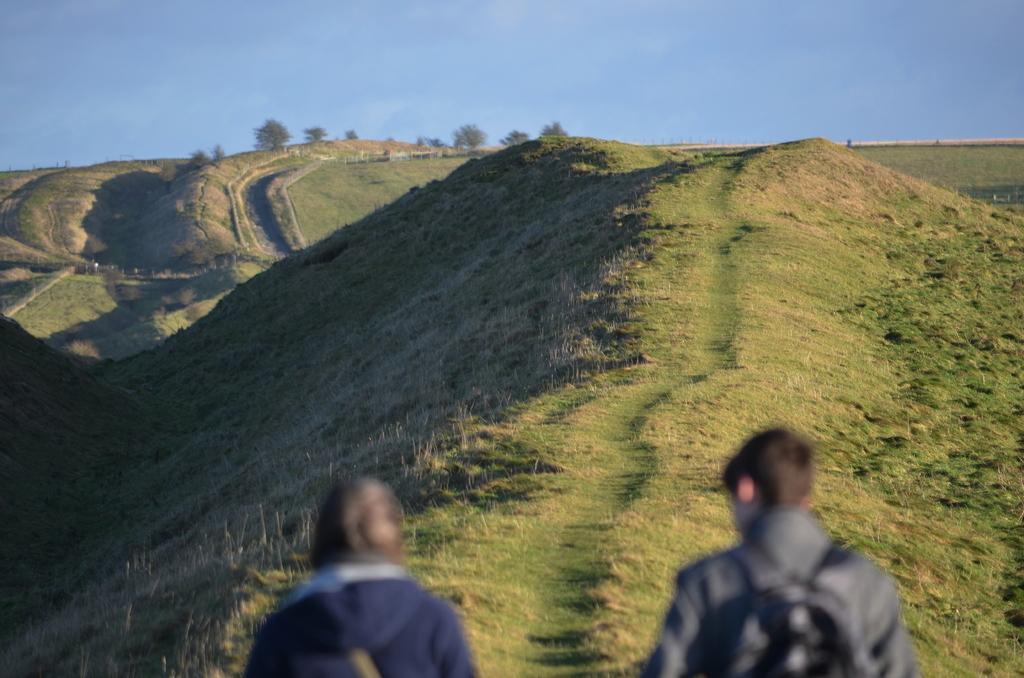Describe this image in one or two sentences. In this image there are two people. In the background of the image there is grass, trees and sky. 